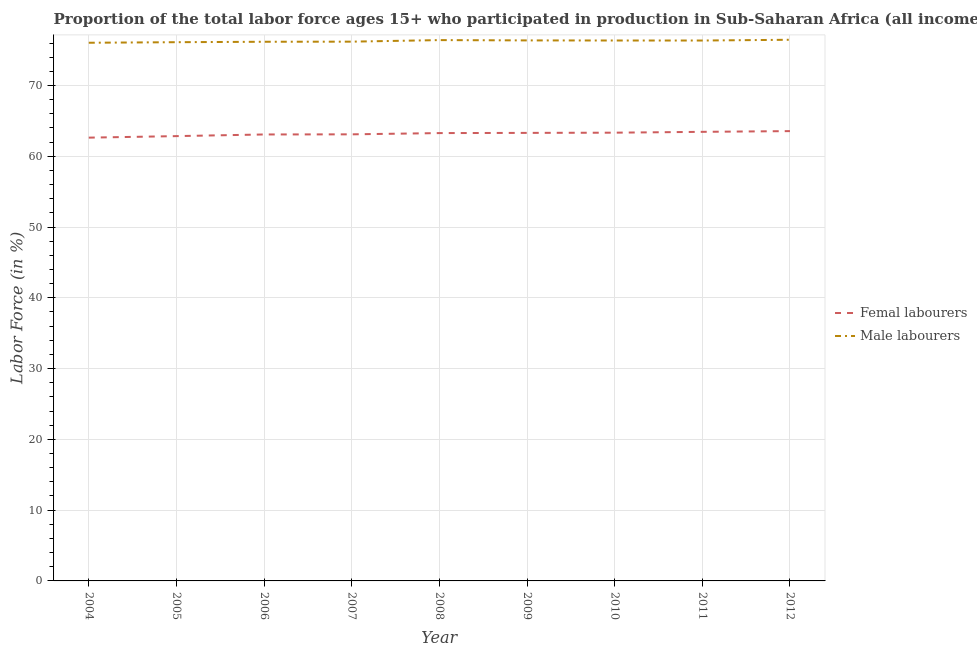Is the number of lines equal to the number of legend labels?
Provide a short and direct response. Yes. What is the percentage of male labour force in 2009?
Keep it short and to the point. 76.37. Across all years, what is the maximum percentage of male labour force?
Ensure brevity in your answer.  76.46. Across all years, what is the minimum percentage of male labour force?
Provide a short and direct response. 76.04. In which year was the percentage of male labour force maximum?
Make the answer very short. 2012. What is the total percentage of female labor force in the graph?
Give a very brief answer. 568.57. What is the difference between the percentage of female labor force in 2005 and that in 2009?
Offer a very short reply. -0.46. What is the difference between the percentage of female labor force in 2010 and the percentage of male labour force in 2011?
Your response must be concise. -13.02. What is the average percentage of female labor force per year?
Provide a succinct answer. 63.17. In the year 2008, what is the difference between the percentage of male labour force and percentage of female labor force?
Provide a short and direct response. 13.14. What is the ratio of the percentage of female labor force in 2004 to that in 2008?
Your answer should be compact. 0.99. Is the percentage of female labor force in 2009 less than that in 2010?
Give a very brief answer. Yes. What is the difference between the highest and the second highest percentage of female labor force?
Make the answer very short. 0.1. What is the difference between the highest and the lowest percentage of male labour force?
Ensure brevity in your answer.  0.42. Is the sum of the percentage of male labour force in 2010 and 2011 greater than the maximum percentage of female labor force across all years?
Offer a very short reply. Yes. Is the percentage of male labour force strictly greater than the percentage of female labor force over the years?
Ensure brevity in your answer.  Yes. Is the percentage of female labor force strictly less than the percentage of male labour force over the years?
Ensure brevity in your answer.  Yes. How many lines are there?
Provide a short and direct response. 2. What is the difference between two consecutive major ticks on the Y-axis?
Provide a short and direct response. 10. Are the values on the major ticks of Y-axis written in scientific E-notation?
Give a very brief answer. No. Does the graph contain any zero values?
Provide a succinct answer. No. Does the graph contain grids?
Give a very brief answer. Yes. How many legend labels are there?
Your answer should be compact. 2. What is the title of the graph?
Ensure brevity in your answer.  Proportion of the total labor force ages 15+ who participated in production in Sub-Saharan Africa (all income levels). Does "Constant 2005 US$" appear as one of the legend labels in the graph?
Keep it short and to the point. No. What is the label or title of the Y-axis?
Your answer should be compact. Labor Force (in %). What is the Labor Force (in %) in Femal labourers in 2004?
Your answer should be very brief. 62.63. What is the Labor Force (in %) of Male labourers in 2004?
Ensure brevity in your answer.  76.04. What is the Labor Force (in %) of Femal labourers in 2005?
Offer a terse response. 62.85. What is the Labor Force (in %) in Male labourers in 2005?
Your answer should be compact. 76.12. What is the Labor Force (in %) in Femal labourers in 2006?
Provide a short and direct response. 63.08. What is the Labor Force (in %) of Male labourers in 2006?
Give a very brief answer. 76.18. What is the Labor Force (in %) in Femal labourers in 2007?
Your answer should be very brief. 63.1. What is the Labor Force (in %) in Male labourers in 2007?
Offer a very short reply. 76.19. What is the Labor Force (in %) in Femal labourers in 2008?
Give a very brief answer. 63.27. What is the Labor Force (in %) of Male labourers in 2008?
Your response must be concise. 76.41. What is the Labor Force (in %) in Femal labourers in 2009?
Your answer should be compact. 63.3. What is the Labor Force (in %) of Male labourers in 2009?
Your response must be concise. 76.37. What is the Labor Force (in %) of Femal labourers in 2010?
Provide a succinct answer. 63.33. What is the Labor Force (in %) of Male labourers in 2010?
Your response must be concise. 76.36. What is the Labor Force (in %) of Femal labourers in 2011?
Offer a terse response. 63.45. What is the Labor Force (in %) of Male labourers in 2011?
Make the answer very short. 76.35. What is the Labor Force (in %) in Femal labourers in 2012?
Your response must be concise. 63.55. What is the Labor Force (in %) of Male labourers in 2012?
Your answer should be very brief. 76.46. Across all years, what is the maximum Labor Force (in %) in Femal labourers?
Make the answer very short. 63.55. Across all years, what is the maximum Labor Force (in %) in Male labourers?
Keep it short and to the point. 76.46. Across all years, what is the minimum Labor Force (in %) of Femal labourers?
Provide a short and direct response. 62.63. Across all years, what is the minimum Labor Force (in %) of Male labourers?
Give a very brief answer. 76.04. What is the total Labor Force (in %) of Femal labourers in the graph?
Provide a short and direct response. 568.57. What is the total Labor Force (in %) of Male labourers in the graph?
Give a very brief answer. 686.48. What is the difference between the Labor Force (in %) in Femal labourers in 2004 and that in 2005?
Provide a short and direct response. -0.22. What is the difference between the Labor Force (in %) in Male labourers in 2004 and that in 2005?
Provide a succinct answer. -0.08. What is the difference between the Labor Force (in %) in Femal labourers in 2004 and that in 2006?
Provide a short and direct response. -0.45. What is the difference between the Labor Force (in %) in Male labourers in 2004 and that in 2006?
Keep it short and to the point. -0.14. What is the difference between the Labor Force (in %) of Femal labourers in 2004 and that in 2007?
Your answer should be compact. -0.47. What is the difference between the Labor Force (in %) in Male labourers in 2004 and that in 2007?
Provide a succinct answer. -0.16. What is the difference between the Labor Force (in %) in Femal labourers in 2004 and that in 2008?
Make the answer very short. -0.64. What is the difference between the Labor Force (in %) in Male labourers in 2004 and that in 2008?
Ensure brevity in your answer.  -0.38. What is the difference between the Labor Force (in %) in Femal labourers in 2004 and that in 2009?
Keep it short and to the point. -0.67. What is the difference between the Labor Force (in %) in Male labourers in 2004 and that in 2009?
Keep it short and to the point. -0.33. What is the difference between the Labor Force (in %) of Femal labourers in 2004 and that in 2010?
Your response must be concise. -0.7. What is the difference between the Labor Force (in %) of Male labourers in 2004 and that in 2010?
Offer a terse response. -0.32. What is the difference between the Labor Force (in %) in Femal labourers in 2004 and that in 2011?
Offer a terse response. -0.82. What is the difference between the Labor Force (in %) in Male labourers in 2004 and that in 2011?
Offer a terse response. -0.32. What is the difference between the Labor Force (in %) of Femal labourers in 2004 and that in 2012?
Provide a short and direct response. -0.92. What is the difference between the Labor Force (in %) of Male labourers in 2004 and that in 2012?
Ensure brevity in your answer.  -0.42. What is the difference between the Labor Force (in %) of Femal labourers in 2005 and that in 2006?
Offer a terse response. -0.23. What is the difference between the Labor Force (in %) of Male labourers in 2005 and that in 2006?
Offer a very short reply. -0.06. What is the difference between the Labor Force (in %) of Femal labourers in 2005 and that in 2007?
Provide a succinct answer. -0.25. What is the difference between the Labor Force (in %) in Male labourers in 2005 and that in 2007?
Your answer should be compact. -0.08. What is the difference between the Labor Force (in %) in Femal labourers in 2005 and that in 2008?
Provide a succinct answer. -0.43. What is the difference between the Labor Force (in %) in Male labourers in 2005 and that in 2008?
Your answer should be very brief. -0.3. What is the difference between the Labor Force (in %) in Femal labourers in 2005 and that in 2009?
Offer a very short reply. -0.46. What is the difference between the Labor Force (in %) of Male labourers in 2005 and that in 2009?
Your response must be concise. -0.25. What is the difference between the Labor Force (in %) in Femal labourers in 2005 and that in 2010?
Your answer should be compact. -0.49. What is the difference between the Labor Force (in %) of Male labourers in 2005 and that in 2010?
Give a very brief answer. -0.24. What is the difference between the Labor Force (in %) of Femal labourers in 2005 and that in 2011?
Offer a terse response. -0.6. What is the difference between the Labor Force (in %) of Male labourers in 2005 and that in 2011?
Keep it short and to the point. -0.24. What is the difference between the Labor Force (in %) of Femal labourers in 2005 and that in 2012?
Keep it short and to the point. -0.71. What is the difference between the Labor Force (in %) of Male labourers in 2005 and that in 2012?
Your response must be concise. -0.34. What is the difference between the Labor Force (in %) in Femal labourers in 2006 and that in 2007?
Your response must be concise. -0.02. What is the difference between the Labor Force (in %) of Male labourers in 2006 and that in 2007?
Provide a succinct answer. -0.02. What is the difference between the Labor Force (in %) in Femal labourers in 2006 and that in 2008?
Give a very brief answer. -0.19. What is the difference between the Labor Force (in %) of Male labourers in 2006 and that in 2008?
Give a very brief answer. -0.23. What is the difference between the Labor Force (in %) in Femal labourers in 2006 and that in 2009?
Offer a terse response. -0.22. What is the difference between the Labor Force (in %) in Male labourers in 2006 and that in 2009?
Make the answer very short. -0.19. What is the difference between the Labor Force (in %) in Femal labourers in 2006 and that in 2010?
Offer a very short reply. -0.25. What is the difference between the Labor Force (in %) in Male labourers in 2006 and that in 2010?
Your answer should be very brief. -0.18. What is the difference between the Labor Force (in %) of Femal labourers in 2006 and that in 2011?
Make the answer very short. -0.37. What is the difference between the Labor Force (in %) in Male labourers in 2006 and that in 2011?
Your answer should be compact. -0.17. What is the difference between the Labor Force (in %) of Femal labourers in 2006 and that in 2012?
Give a very brief answer. -0.47. What is the difference between the Labor Force (in %) of Male labourers in 2006 and that in 2012?
Offer a terse response. -0.28. What is the difference between the Labor Force (in %) of Femal labourers in 2007 and that in 2008?
Offer a very short reply. -0.18. What is the difference between the Labor Force (in %) of Male labourers in 2007 and that in 2008?
Your response must be concise. -0.22. What is the difference between the Labor Force (in %) of Femal labourers in 2007 and that in 2009?
Offer a terse response. -0.2. What is the difference between the Labor Force (in %) of Male labourers in 2007 and that in 2009?
Ensure brevity in your answer.  -0.18. What is the difference between the Labor Force (in %) in Femal labourers in 2007 and that in 2010?
Ensure brevity in your answer.  -0.23. What is the difference between the Labor Force (in %) of Male labourers in 2007 and that in 2010?
Your answer should be very brief. -0.16. What is the difference between the Labor Force (in %) of Femal labourers in 2007 and that in 2011?
Your answer should be very brief. -0.35. What is the difference between the Labor Force (in %) of Male labourers in 2007 and that in 2011?
Keep it short and to the point. -0.16. What is the difference between the Labor Force (in %) of Femal labourers in 2007 and that in 2012?
Your answer should be very brief. -0.46. What is the difference between the Labor Force (in %) of Male labourers in 2007 and that in 2012?
Your response must be concise. -0.27. What is the difference between the Labor Force (in %) in Femal labourers in 2008 and that in 2009?
Your answer should be very brief. -0.03. What is the difference between the Labor Force (in %) of Male labourers in 2008 and that in 2009?
Offer a very short reply. 0.04. What is the difference between the Labor Force (in %) of Femal labourers in 2008 and that in 2010?
Make the answer very short. -0.06. What is the difference between the Labor Force (in %) in Male labourers in 2008 and that in 2010?
Ensure brevity in your answer.  0.06. What is the difference between the Labor Force (in %) of Femal labourers in 2008 and that in 2011?
Your answer should be very brief. -0.18. What is the difference between the Labor Force (in %) of Male labourers in 2008 and that in 2011?
Provide a succinct answer. 0.06. What is the difference between the Labor Force (in %) in Femal labourers in 2008 and that in 2012?
Ensure brevity in your answer.  -0.28. What is the difference between the Labor Force (in %) in Male labourers in 2008 and that in 2012?
Your answer should be very brief. -0.05. What is the difference between the Labor Force (in %) of Femal labourers in 2009 and that in 2010?
Ensure brevity in your answer.  -0.03. What is the difference between the Labor Force (in %) in Male labourers in 2009 and that in 2010?
Keep it short and to the point. 0.01. What is the difference between the Labor Force (in %) in Femal labourers in 2009 and that in 2011?
Your answer should be very brief. -0.15. What is the difference between the Labor Force (in %) in Male labourers in 2009 and that in 2011?
Give a very brief answer. 0.02. What is the difference between the Labor Force (in %) in Femal labourers in 2009 and that in 2012?
Offer a terse response. -0.25. What is the difference between the Labor Force (in %) of Male labourers in 2009 and that in 2012?
Ensure brevity in your answer.  -0.09. What is the difference between the Labor Force (in %) in Femal labourers in 2010 and that in 2011?
Give a very brief answer. -0.12. What is the difference between the Labor Force (in %) of Male labourers in 2010 and that in 2011?
Offer a very short reply. 0. What is the difference between the Labor Force (in %) of Femal labourers in 2010 and that in 2012?
Give a very brief answer. -0.22. What is the difference between the Labor Force (in %) of Male labourers in 2010 and that in 2012?
Offer a very short reply. -0.1. What is the difference between the Labor Force (in %) of Femal labourers in 2011 and that in 2012?
Offer a very short reply. -0.1. What is the difference between the Labor Force (in %) of Male labourers in 2011 and that in 2012?
Your answer should be very brief. -0.11. What is the difference between the Labor Force (in %) of Femal labourers in 2004 and the Labor Force (in %) of Male labourers in 2005?
Offer a terse response. -13.49. What is the difference between the Labor Force (in %) of Femal labourers in 2004 and the Labor Force (in %) of Male labourers in 2006?
Give a very brief answer. -13.55. What is the difference between the Labor Force (in %) in Femal labourers in 2004 and the Labor Force (in %) in Male labourers in 2007?
Offer a very short reply. -13.56. What is the difference between the Labor Force (in %) in Femal labourers in 2004 and the Labor Force (in %) in Male labourers in 2008?
Make the answer very short. -13.78. What is the difference between the Labor Force (in %) of Femal labourers in 2004 and the Labor Force (in %) of Male labourers in 2009?
Your answer should be very brief. -13.74. What is the difference between the Labor Force (in %) of Femal labourers in 2004 and the Labor Force (in %) of Male labourers in 2010?
Make the answer very short. -13.72. What is the difference between the Labor Force (in %) in Femal labourers in 2004 and the Labor Force (in %) in Male labourers in 2011?
Ensure brevity in your answer.  -13.72. What is the difference between the Labor Force (in %) of Femal labourers in 2004 and the Labor Force (in %) of Male labourers in 2012?
Keep it short and to the point. -13.83. What is the difference between the Labor Force (in %) of Femal labourers in 2005 and the Labor Force (in %) of Male labourers in 2006?
Your answer should be compact. -13.33. What is the difference between the Labor Force (in %) in Femal labourers in 2005 and the Labor Force (in %) in Male labourers in 2007?
Offer a terse response. -13.35. What is the difference between the Labor Force (in %) of Femal labourers in 2005 and the Labor Force (in %) of Male labourers in 2008?
Keep it short and to the point. -13.57. What is the difference between the Labor Force (in %) of Femal labourers in 2005 and the Labor Force (in %) of Male labourers in 2009?
Your response must be concise. -13.52. What is the difference between the Labor Force (in %) in Femal labourers in 2005 and the Labor Force (in %) in Male labourers in 2010?
Your response must be concise. -13.51. What is the difference between the Labor Force (in %) of Femal labourers in 2005 and the Labor Force (in %) of Male labourers in 2011?
Offer a very short reply. -13.51. What is the difference between the Labor Force (in %) in Femal labourers in 2005 and the Labor Force (in %) in Male labourers in 2012?
Provide a short and direct response. -13.61. What is the difference between the Labor Force (in %) in Femal labourers in 2006 and the Labor Force (in %) in Male labourers in 2007?
Offer a very short reply. -13.11. What is the difference between the Labor Force (in %) in Femal labourers in 2006 and the Labor Force (in %) in Male labourers in 2008?
Your answer should be compact. -13.33. What is the difference between the Labor Force (in %) of Femal labourers in 2006 and the Labor Force (in %) of Male labourers in 2009?
Your answer should be very brief. -13.29. What is the difference between the Labor Force (in %) in Femal labourers in 2006 and the Labor Force (in %) in Male labourers in 2010?
Your response must be concise. -13.28. What is the difference between the Labor Force (in %) of Femal labourers in 2006 and the Labor Force (in %) of Male labourers in 2011?
Give a very brief answer. -13.27. What is the difference between the Labor Force (in %) in Femal labourers in 2006 and the Labor Force (in %) in Male labourers in 2012?
Your answer should be compact. -13.38. What is the difference between the Labor Force (in %) of Femal labourers in 2007 and the Labor Force (in %) of Male labourers in 2008?
Ensure brevity in your answer.  -13.32. What is the difference between the Labor Force (in %) of Femal labourers in 2007 and the Labor Force (in %) of Male labourers in 2009?
Make the answer very short. -13.27. What is the difference between the Labor Force (in %) of Femal labourers in 2007 and the Labor Force (in %) of Male labourers in 2010?
Your response must be concise. -13.26. What is the difference between the Labor Force (in %) of Femal labourers in 2007 and the Labor Force (in %) of Male labourers in 2011?
Your answer should be very brief. -13.26. What is the difference between the Labor Force (in %) of Femal labourers in 2007 and the Labor Force (in %) of Male labourers in 2012?
Your answer should be very brief. -13.36. What is the difference between the Labor Force (in %) of Femal labourers in 2008 and the Labor Force (in %) of Male labourers in 2009?
Your answer should be very brief. -13.09. What is the difference between the Labor Force (in %) of Femal labourers in 2008 and the Labor Force (in %) of Male labourers in 2010?
Provide a succinct answer. -13.08. What is the difference between the Labor Force (in %) of Femal labourers in 2008 and the Labor Force (in %) of Male labourers in 2011?
Offer a terse response. -13.08. What is the difference between the Labor Force (in %) of Femal labourers in 2008 and the Labor Force (in %) of Male labourers in 2012?
Keep it short and to the point. -13.18. What is the difference between the Labor Force (in %) in Femal labourers in 2009 and the Labor Force (in %) in Male labourers in 2010?
Keep it short and to the point. -13.05. What is the difference between the Labor Force (in %) in Femal labourers in 2009 and the Labor Force (in %) in Male labourers in 2011?
Ensure brevity in your answer.  -13.05. What is the difference between the Labor Force (in %) in Femal labourers in 2009 and the Labor Force (in %) in Male labourers in 2012?
Give a very brief answer. -13.16. What is the difference between the Labor Force (in %) in Femal labourers in 2010 and the Labor Force (in %) in Male labourers in 2011?
Your answer should be compact. -13.02. What is the difference between the Labor Force (in %) in Femal labourers in 2010 and the Labor Force (in %) in Male labourers in 2012?
Your answer should be compact. -13.13. What is the difference between the Labor Force (in %) of Femal labourers in 2011 and the Labor Force (in %) of Male labourers in 2012?
Provide a succinct answer. -13.01. What is the average Labor Force (in %) in Femal labourers per year?
Provide a succinct answer. 63.17. What is the average Labor Force (in %) in Male labourers per year?
Your answer should be compact. 76.28. In the year 2004, what is the difference between the Labor Force (in %) of Femal labourers and Labor Force (in %) of Male labourers?
Offer a very short reply. -13.41. In the year 2005, what is the difference between the Labor Force (in %) of Femal labourers and Labor Force (in %) of Male labourers?
Offer a very short reply. -13.27. In the year 2006, what is the difference between the Labor Force (in %) in Femal labourers and Labor Force (in %) in Male labourers?
Offer a terse response. -13.1. In the year 2007, what is the difference between the Labor Force (in %) in Femal labourers and Labor Force (in %) in Male labourers?
Ensure brevity in your answer.  -13.1. In the year 2008, what is the difference between the Labor Force (in %) of Femal labourers and Labor Force (in %) of Male labourers?
Provide a short and direct response. -13.14. In the year 2009, what is the difference between the Labor Force (in %) of Femal labourers and Labor Force (in %) of Male labourers?
Your answer should be compact. -13.07. In the year 2010, what is the difference between the Labor Force (in %) of Femal labourers and Labor Force (in %) of Male labourers?
Make the answer very short. -13.02. In the year 2011, what is the difference between the Labor Force (in %) of Femal labourers and Labor Force (in %) of Male labourers?
Give a very brief answer. -12.9. In the year 2012, what is the difference between the Labor Force (in %) of Femal labourers and Labor Force (in %) of Male labourers?
Provide a short and direct response. -12.91. What is the ratio of the Labor Force (in %) of Femal labourers in 2004 to that in 2005?
Make the answer very short. 1. What is the ratio of the Labor Force (in %) of Male labourers in 2004 to that in 2007?
Make the answer very short. 1. What is the ratio of the Labor Force (in %) of Femal labourers in 2004 to that in 2008?
Make the answer very short. 0.99. What is the ratio of the Labor Force (in %) in Femal labourers in 2004 to that in 2009?
Offer a terse response. 0.99. What is the ratio of the Labor Force (in %) in Femal labourers in 2004 to that in 2010?
Provide a short and direct response. 0.99. What is the ratio of the Labor Force (in %) of Femal labourers in 2004 to that in 2011?
Keep it short and to the point. 0.99. What is the ratio of the Labor Force (in %) in Male labourers in 2004 to that in 2011?
Give a very brief answer. 1. What is the ratio of the Labor Force (in %) in Femal labourers in 2004 to that in 2012?
Offer a terse response. 0.99. What is the ratio of the Labor Force (in %) in Male labourers in 2004 to that in 2012?
Make the answer very short. 0.99. What is the ratio of the Labor Force (in %) of Femal labourers in 2005 to that in 2006?
Your response must be concise. 1. What is the ratio of the Labor Force (in %) in Male labourers in 2005 to that in 2006?
Make the answer very short. 1. What is the ratio of the Labor Force (in %) in Male labourers in 2005 to that in 2007?
Make the answer very short. 1. What is the ratio of the Labor Force (in %) of Femal labourers in 2005 to that in 2009?
Your answer should be compact. 0.99. What is the ratio of the Labor Force (in %) of Male labourers in 2005 to that in 2009?
Your answer should be very brief. 1. What is the ratio of the Labor Force (in %) in Femal labourers in 2005 to that in 2011?
Ensure brevity in your answer.  0.99. What is the ratio of the Labor Force (in %) of Male labourers in 2005 to that in 2011?
Provide a succinct answer. 1. What is the ratio of the Labor Force (in %) of Femal labourers in 2005 to that in 2012?
Your answer should be compact. 0.99. What is the ratio of the Labor Force (in %) in Femal labourers in 2006 to that in 2007?
Your answer should be very brief. 1. What is the ratio of the Labor Force (in %) of Male labourers in 2006 to that in 2007?
Provide a short and direct response. 1. What is the ratio of the Labor Force (in %) of Femal labourers in 2006 to that in 2008?
Offer a very short reply. 1. What is the ratio of the Labor Force (in %) of Femal labourers in 2006 to that in 2009?
Keep it short and to the point. 1. What is the ratio of the Labor Force (in %) in Femal labourers in 2006 to that in 2011?
Keep it short and to the point. 0.99. What is the ratio of the Labor Force (in %) of Femal labourers in 2007 to that in 2008?
Make the answer very short. 1. What is the ratio of the Labor Force (in %) in Male labourers in 2007 to that in 2009?
Offer a very short reply. 1. What is the ratio of the Labor Force (in %) in Femal labourers in 2007 to that in 2010?
Provide a short and direct response. 1. What is the ratio of the Labor Force (in %) of Male labourers in 2007 to that in 2010?
Keep it short and to the point. 1. What is the ratio of the Labor Force (in %) of Male labourers in 2007 to that in 2012?
Give a very brief answer. 1. What is the ratio of the Labor Force (in %) in Femal labourers in 2008 to that in 2009?
Give a very brief answer. 1. What is the ratio of the Labor Force (in %) of Male labourers in 2008 to that in 2009?
Provide a short and direct response. 1. What is the ratio of the Labor Force (in %) in Femal labourers in 2008 to that in 2010?
Give a very brief answer. 1. What is the ratio of the Labor Force (in %) of Male labourers in 2008 to that in 2010?
Your answer should be compact. 1. What is the ratio of the Labor Force (in %) in Femal labourers in 2008 to that in 2011?
Make the answer very short. 1. What is the ratio of the Labor Force (in %) in Male labourers in 2008 to that in 2011?
Offer a terse response. 1. What is the ratio of the Labor Force (in %) in Femal labourers in 2008 to that in 2012?
Your answer should be compact. 1. What is the ratio of the Labor Force (in %) in Male labourers in 2008 to that in 2012?
Your response must be concise. 1. What is the ratio of the Labor Force (in %) in Femal labourers in 2009 to that in 2010?
Give a very brief answer. 1. What is the ratio of the Labor Force (in %) in Male labourers in 2009 to that in 2010?
Provide a succinct answer. 1. What is the ratio of the Labor Force (in %) of Male labourers in 2009 to that in 2011?
Provide a succinct answer. 1. What is the ratio of the Labor Force (in %) in Male labourers in 2009 to that in 2012?
Keep it short and to the point. 1. What is the ratio of the Labor Force (in %) in Femal labourers in 2011 to that in 2012?
Your response must be concise. 1. What is the ratio of the Labor Force (in %) of Male labourers in 2011 to that in 2012?
Your response must be concise. 1. What is the difference between the highest and the second highest Labor Force (in %) in Femal labourers?
Provide a short and direct response. 0.1. What is the difference between the highest and the second highest Labor Force (in %) in Male labourers?
Keep it short and to the point. 0.05. What is the difference between the highest and the lowest Labor Force (in %) of Femal labourers?
Offer a terse response. 0.92. What is the difference between the highest and the lowest Labor Force (in %) in Male labourers?
Make the answer very short. 0.42. 